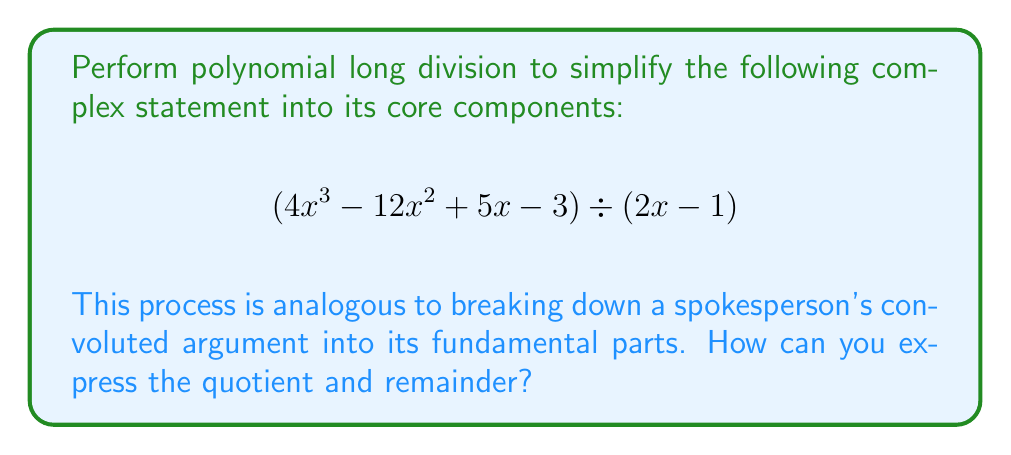Can you solve this math problem? Let's break down this complex statement using polynomial long division:

1) Set up the division:
   $$\frac{4x^3 - 12x^2 + 5x - 3}{2x - 1}$$

2) Divide $4x^3$ by $2x$:
   $$2x^2$$
   Multiply $(2x - 1)(2x^2) = 4x^3 - 2x^2$
   Subtract: $4x^3 - 12x^2 - (4x^3 - 2x^2) = -10x^2$

3) Bring down $5x$:
   $$-10x^2 + 5x$$
   Divide $-10x^2$ by $2x$:
   $$-5x$$
   Multiply $(2x - 1)(-5x) = -10x^2 + 5x$
   Subtract: $-10x^2 + 5x - (-10x^2 + 5x) = 0$

4) Bring down $-3$:
   $$-3$$
   Divide $-3$ by $2x$:
   $$\frac{-3}{2x}$$
   This cannot be divided further, so it becomes our remainder.

5) The final result is:
   Quotient: $2x^2 - 5x$
   Remainder: $-3$

Therefore, we can express the result as:
$$(4x^3 - 12x^2 + 5x - 3) \div (2x - 1) = 2x^2 - 5x + \frac{-3}{2x - 1}$$

This process demonstrates how a complex statement (or argument) can be broken down into simpler, more manageable components.
Answer: $2x^2 - 5x + \frac{-3}{2x - 1}$ 